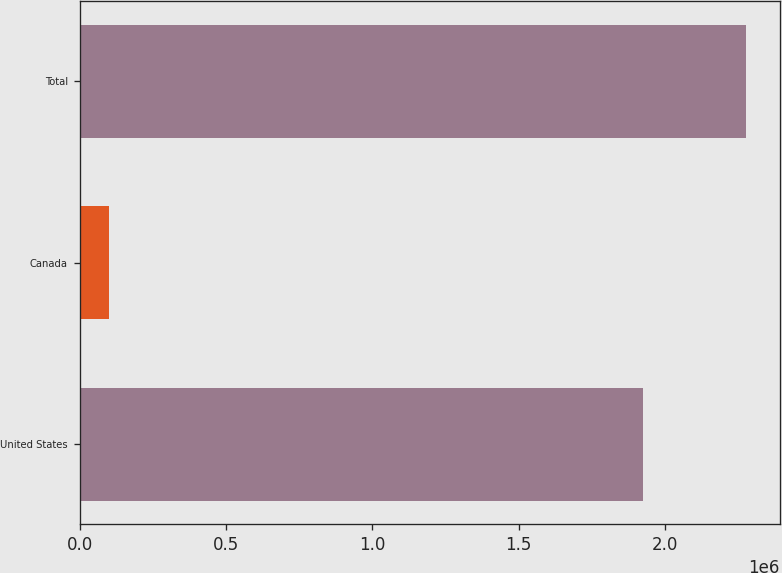Convert chart. <chart><loc_0><loc_0><loc_500><loc_500><bar_chart><fcel>United States<fcel>Canada<fcel>Total<nl><fcel>1.92633e+06<fcel>100446<fcel>2.27722e+06<nl></chart> 